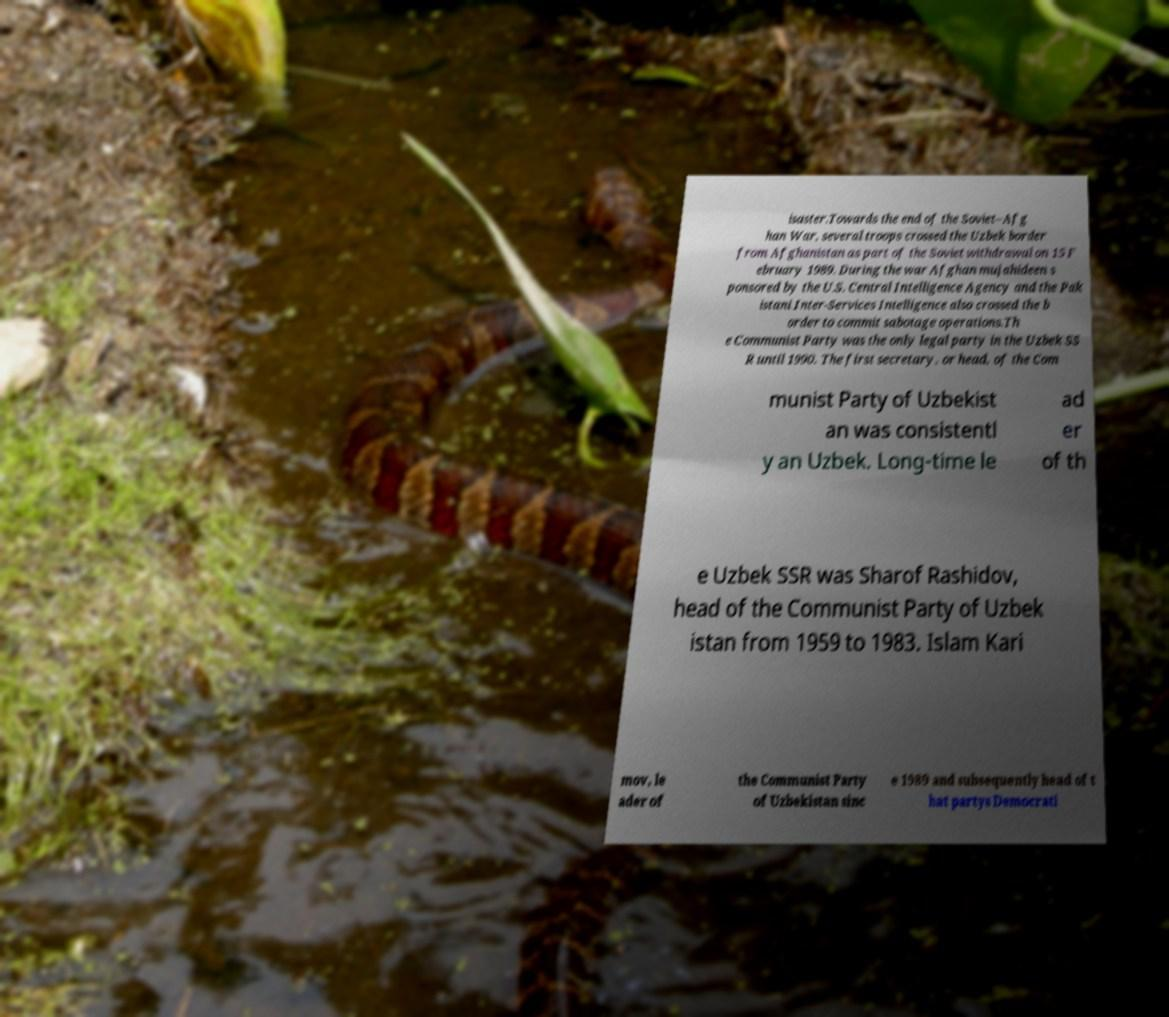There's text embedded in this image that I need extracted. Can you transcribe it verbatim? isaster.Towards the end of the Soviet–Afg han War, several troops crossed the Uzbek border from Afghanistan as part of the Soviet withdrawal on 15 F ebruary 1989. During the war Afghan mujahideen s ponsored by the U.S. Central Intelligence Agency and the Pak istani Inter-Services Intelligence also crossed the b order to commit sabotage operations.Th e Communist Party was the only legal party in the Uzbek SS R until 1990. The first secretary, or head, of the Com munist Party of Uzbekist an was consistentl y an Uzbek. Long-time le ad er of th e Uzbek SSR was Sharof Rashidov, head of the Communist Party of Uzbek istan from 1959 to 1983. Islam Kari mov, le ader of the Communist Party of Uzbekistan sinc e 1989 and subsequently head of t hat partys Democrati 